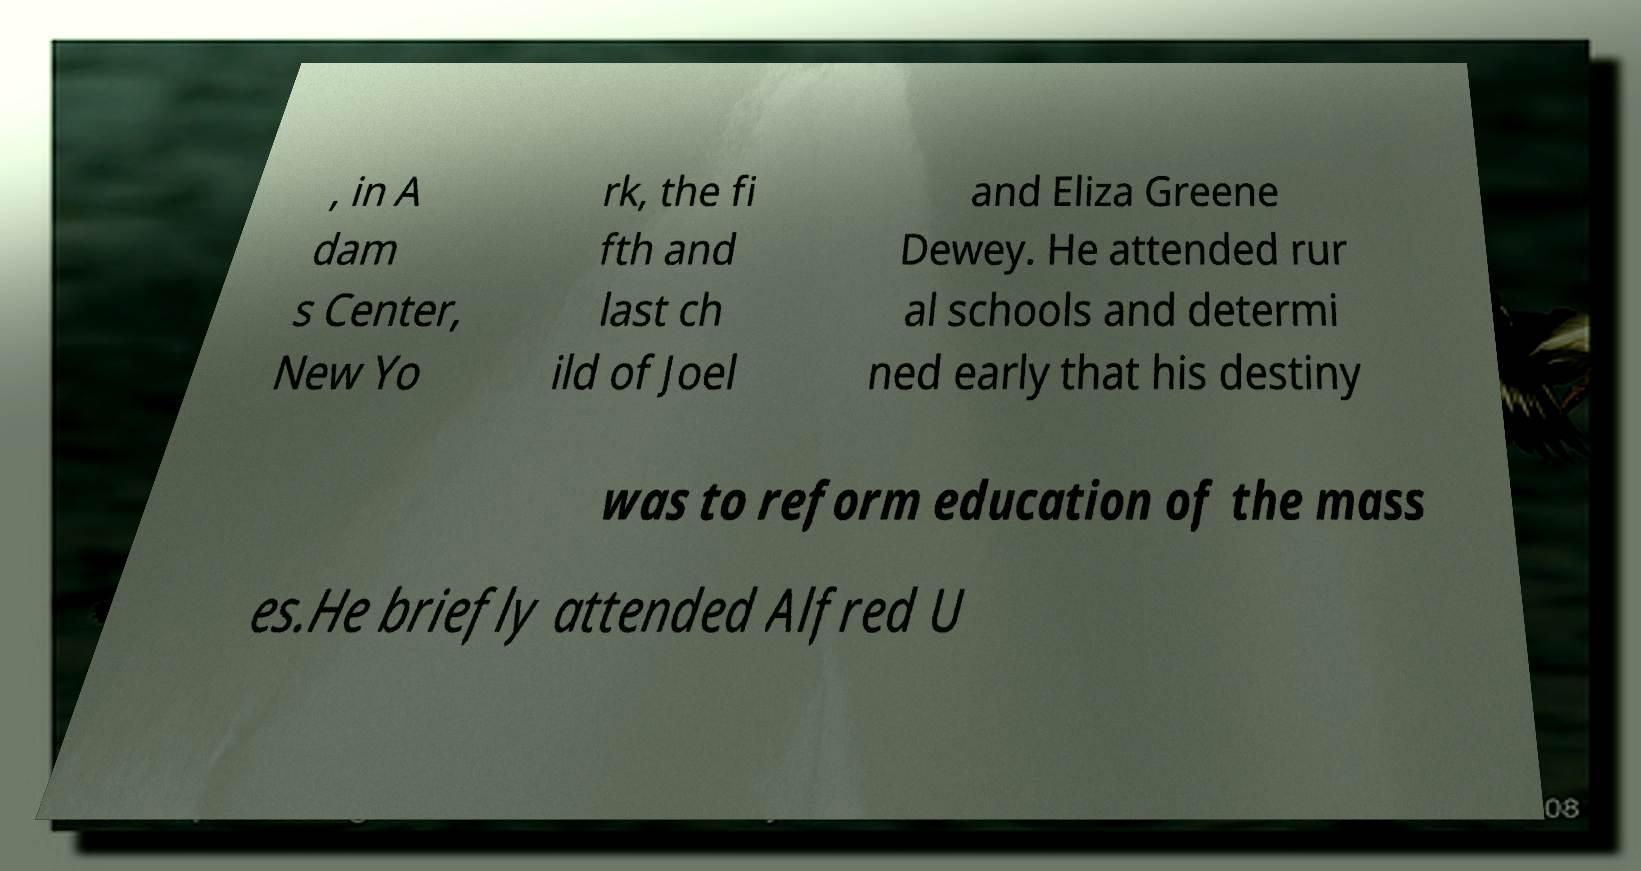Can you accurately transcribe the text from the provided image for me? , in A dam s Center, New Yo rk, the fi fth and last ch ild of Joel and Eliza Greene Dewey. He attended rur al schools and determi ned early that his destiny was to reform education of the mass es.He briefly attended Alfred U 